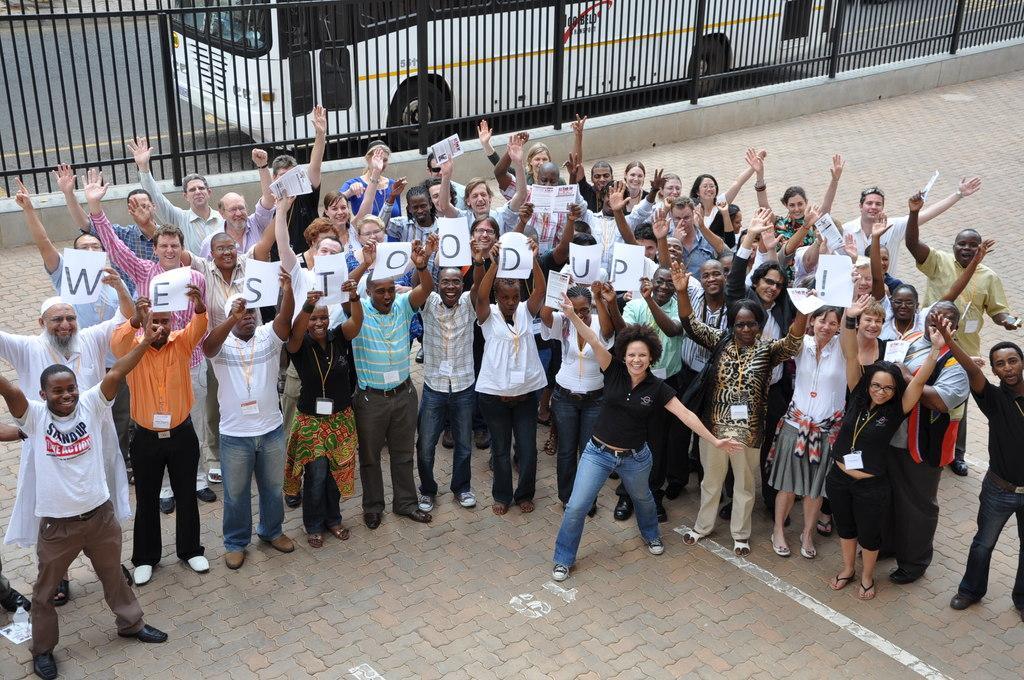How would you summarize this image in a sentence or two? In the background we can see a vehicle on the road. In this picture we can see a railing. We can see a group of people. Among them few are holding papers. At the bottom portion of the picture we can see a water bottle. 